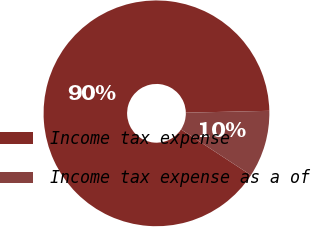Convert chart. <chart><loc_0><loc_0><loc_500><loc_500><pie_chart><fcel>Income tax expense<fcel>Income tax expense as a of<nl><fcel>90.42%<fcel>9.58%<nl></chart> 